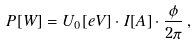Convert formula to latex. <formula><loc_0><loc_0><loc_500><loc_500>P [ W ] = U _ { 0 } [ e V ] \cdot I [ A ] \cdot \frac { \phi } { 2 \pi } \, ,</formula> 